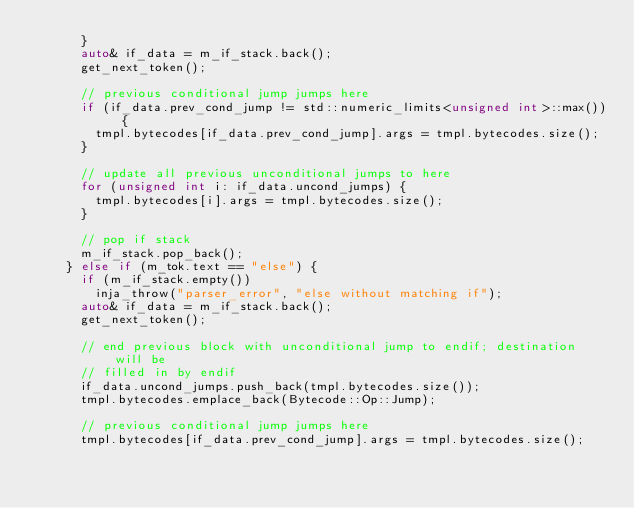Convert code to text. <code><loc_0><loc_0><loc_500><loc_500><_C++_>      }
      auto& if_data = m_if_stack.back();
      get_next_token();

      // previous conditional jump jumps here
      if (if_data.prev_cond_jump != std::numeric_limits<unsigned int>::max()) {
        tmpl.bytecodes[if_data.prev_cond_jump].args = tmpl.bytecodes.size();
      }

      // update all previous unconditional jumps to here
      for (unsigned int i: if_data.uncond_jumps) {
        tmpl.bytecodes[i].args = tmpl.bytecodes.size();
      }

      // pop if stack
      m_if_stack.pop_back();
    } else if (m_tok.text == "else") {
      if (m_if_stack.empty())
        inja_throw("parser_error", "else without matching if");
      auto& if_data = m_if_stack.back();
      get_next_token();

      // end previous block with unconditional jump to endif; destination will be
      // filled in by endif
      if_data.uncond_jumps.push_back(tmpl.bytecodes.size());
      tmpl.bytecodes.emplace_back(Bytecode::Op::Jump);

      // previous conditional jump jumps here
      tmpl.bytecodes[if_data.prev_cond_jump].args = tmpl.bytecodes.size();</code> 